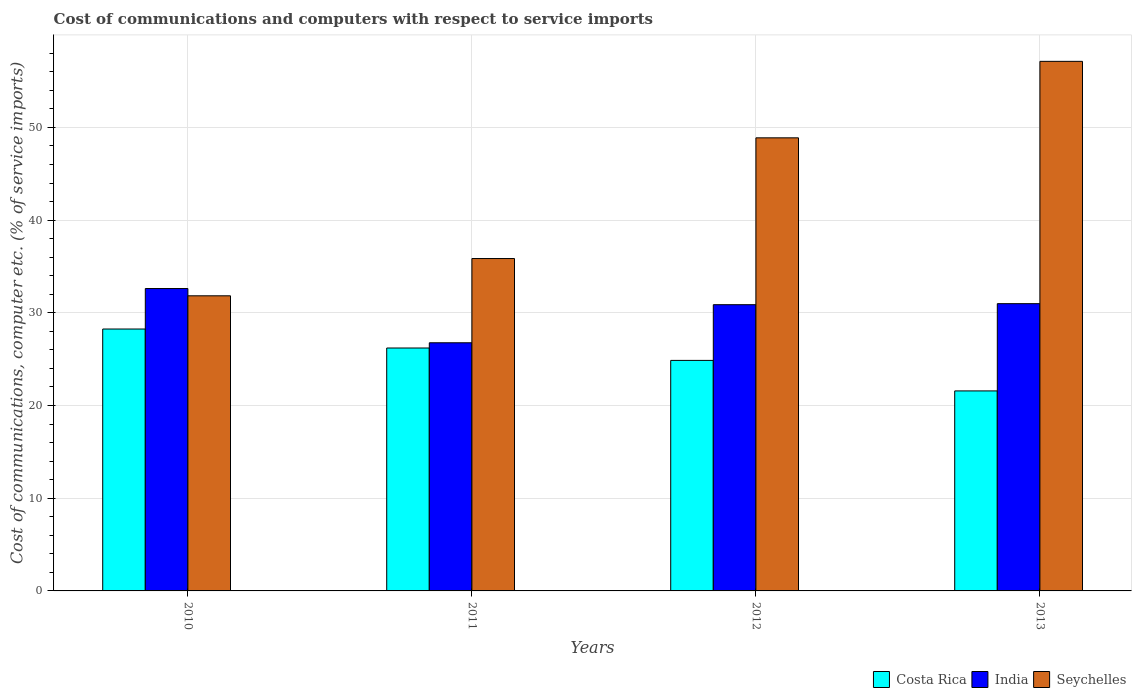How many different coloured bars are there?
Your response must be concise. 3. Are the number of bars on each tick of the X-axis equal?
Your answer should be compact. Yes. How many bars are there on the 4th tick from the left?
Provide a short and direct response. 3. How many bars are there on the 2nd tick from the right?
Give a very brief answer. 3. What is the cost of communications and computers in Costa Rica in 2011?
Make the answer very short. 26.2. Across all years, what is the maximum cost of communications and computers in Seychelles?
Ensure brevity in your answer.  57.13. Across all years, what is the minimum cost of communications and computers in Costa Rica?
Give a very brief answer. 21.58. In which year was the cost of communications and computers in Costa Rica maximum?
Keep it short and to the point. 2010. In which year was the cost of communications and computers in India minimum?
Give a very brief answer. 2011. What is the total cost of communications and computers in Seychelles in the graph?
Offer a very short reply. 173.69. What is the difference between the cost of communications and computers in Costa Rica in 2010 and that in 2011?
Your answer should be compact. 2.05. What is the difference between the cost of communications and computers in Seychelles in 2011 and the cost of communications and computers in India in 2013?
Provide a succinct answer. 4.87. What is the average cost of communications and computers in Seychelles per year?
Offer a very short reply. 43.42. In the year 2012, what is the difference between the cost of communications and computers in Costa Rica and cost of communications and computers in India?
Provide a short and direct response. -6.01. In how many years, is the cost of communications and computers in Costa Rica greater than 28 %?
Ensure brevity in your answer.  1. What is the ratio of the cost of communications and computers in Costa Rica in 2010 to that in 2012?
Your answer should be compact. 1.14. What is the difference between the highest and the second highest cost of communications and computers in Seychelles?
Offer a very short reply. 8.25. What is the difference between the highest and the lowest cost of communications and computers in Seychelles?
Offer a very short reply. 25.29. What does the 2nd bar from the left in 2010 represents?
Your answer should be compact. India. What does the 1st bar from the right in 2012 represents?
Your answer should be compact. Seychelles. How many bars are there?
Ensure brevity in your answer.  12. Are all the bars in the graph horizontal?
Keep it short and to the point. No. What is the difference between two consecutive major ticks on the Y-axis?
Keep it short and to the point. 10. Are the values on the major ticks of Y-axis written in scientific E-notation?
Your response must be concise. No. How many legend labels are there?
Offer a very short reply. 3. What is the title of the graph?
Ensure brevity in your answer.  Cost of communications and computers with respect to service imports. What is the label or title of the Y-axis?
Provide a succinct answer. Cost of communications, computer etc. (% of service imports). What is the Cost of communications, computer etc. (% of service imports) in Costa Rica in 2010?
Your answer should be compact. 28.25. What is the Cost of communications, computer etc. (% of service imports) of India in 2010?
Offer a terse response. 32.62. What is the Cost of communications, computer etc. (% of service imports) of Seychelles in 2010?
Ensure brevity in your answer.  31.83. What is the Cost of communications, computer etc. (% of service imports) of Costa Rica in 2011?
Ensure brevity in your answer.  26.2. What is the Cost of communications, computer etc. (% of service imports) of India in 2011?
Offer a terse response. 26.77. What is the Cost of communications, computer etc. (% of service imports) in Seychelles in 2011?
Your answer should be very brief. 35.86. What is the Cost of communications, computer etc. (% of service imports) in Costa Rica in 2012?
Ensure brevity in your answer.  24.87. What is the Cost of communications, computer etc. (% of service imports) in India in 2012?
Provide a short and direct response. 30.87. What is the Cost of communications, computer etc. (% of service imports) in Seychelles in 2012?
Make the answer very short. 48.88. What is the Cost of communications, computer etc. (% of service imports) of Costa Rica in 2013?
Offer a very short reply. 21.58. What is the Cost of communications, computer etc. (% of service imports) of India in 2013?
Provide a succinct answer. 30.99. What is the Cost of communications, computer etc. (% of service imports) of Seychelles in 2013?
Give a very brief answer. 57.13. Across all years, what is the maximum Cost of communications, computer etc. (% of service imports) in Costa Rica?
Make the answer very short. 28.25. Across all years, what is the maximum Cost of communications, computer etc. (% of service imports) of India?
Your answer should be very brief. 32.62. Across all years, what is the maximum Cost of communications, computer etc. (% of service imports) of Seychelles?
Offer a terse response. 57.13. Across all years, what is the minimum Cost of communications, computer etc. (% of service imports) in Costa Rica?
Offer a very short reply. 21.58. Across all years, what is the minimum Cost of communications, computer etc. (% of service imports) of India?
Your response must be concise. 26.77. Across all years, what is the minimum Cost of communications, computer etc. (% of service imports) in Seychelles?
Ensure brevity in your answer.  31.83. What is the total Cost of communications, computer etc. (% of service imports) of Costa Rica in the graph?
Provide a succinct answer. 100.9. What is the total Cost of communications, computer etc. (% of service imports) in India in the graph?
Make the answer very short. 121.25. What is the total Cost of communications, computer etc. (% of service imports) of Seychelles in the graph?
Your answer should be compact. 173.69. What is the difference between the Cost of communications, computer etc. (% of service imports) in Costa Rica in 2010 and that in 2011?
Provide a succinct answer. 2.05. What is the difference between the Cost of communications, computer etc. (% of service imports) in India in 2010 and that in 2011?
Make the answer very short. 5.85. What is the difference between the Cost of communications, computer etc. (% of service imports) of Seychelles in 2010 and that in 2011?
Keep it short and to the point. -4.02. What is the difference between the Cost of communications, computer etc. (% of service imports) of Costa Rica in 2010 and that in 2012?
Give a very brief answer. 3.38. What is the difference between the Cost of communications, computer etc. (% of service imports) of India in 2010 and that in 2012?
Provide a succinct answer. 1.74. What is the difference between the Cost of communications, computer etc. (% of service imports) of Seychelles in 2010 and that in 2012?
Make the answer very short. -17.04. What is the difference between the Cost of communications, computer etc. (% of service imports) of Costa Rica in 2010 and that in 2013?
Your response must be concise. 6.68. What is the difference between the Cost of communications, computer etc. (% of service imports) of India in 2010 and that in 2013?
Give a very brief answer. 1.63. What is the difference between the Cost of communications, computer etc. (% of service imports) of Seychelles in 2010 and that in 2013?
Offer a terse response. -25.29. What is the difference between the Cost of communications, computer etc. (% of service imports) in Costa Rica in 2011 and that in 2012?
Keep it short and to the point. 1.34. What is the difference between the Cost of communications, computer etc. (% of service imports) of India in 2011 and that in 2012?
Provide a short and direct response. -4.11. What is the difference between the Cost of communications, computer etc. (% of service imports) of Seychelles in 2011 and that in 2012?
Provide a succinct answer. -13.02. What is the difference between the Cost of communications, computer etc. (% of service imports) in Costa Rica in 2011 and that in 2013?
Provide a succinct answer. 4.63. What is the difference between the Cost of communications, computer etc. (% of service imports) of India in 2011 and that in 2013?
Your answer should be compact. -4.22. What is the difference between the Cost of communications, computer etc. (% of service imports) in Seychelles in 2011 and that in 2013?
Make the answer very short. -21.27. What is the difference between the Cost of communications, computer etc. (% of service imports) in Costa Rica in 2012 and that in 2013?
Your response must be concise. 3.29. What is the difference between the Cost of communications, computer etc. (% of service imports) of India in 2012 and that in 2013?
Offer a very short reply. -0.11. What is the difference between the Cost of communications, computer etc. (% of service imports) of Seychelles in 2012 and that in 2013?
Offer a very short reply. -8.25. What is the difference between the Cost of communications, computer etc. (% of service imports) in Costa Rica in 2010 and the Cost of communications, computer etc. (% of service imports) in India in 2011?
Your answer should be very brief. 1.48. What is the difference between the Cost of communications, computer etc. (% of service imports) in Costa Rica in 2010 and the Cost of communications, computer etc. (% of service imports) in Seychelles in 2011?
Offer a terse response. -7.6. What is the difference between the Cost of communications, computer etc. (% of service imports) in India in 2010 and the Cost of communications, computer etc. (% of service imports) in Seychelles in 2011?
Your answer should be compact. -3.24. What is the difference between the Cost of communications, computer etc. (% of service imports) of Costa Rica in 2010 and the Cost of communications, computer etc. (% of service imports) of India in 2012?
Provide a short and direct response. -2.62. What is the difference between the Cost of communications, computer etc. (% of service imports) of Costa Rica in 2010 and the Cost of communications, computer etc. (% of service imports) of Seychelles in 2012?
Make the answer very short. -20.62. What is the difference between the Cost of communications, computer etc. (% of service imports) of India in 2010 and the Cost of communications, computer etc. (% of service imports) of Seychelles in 2012?
Ensure brevity in your answer.  -16.26. What is the difference between the Cost of communications, computer etc. (% of service imports) of Costa Rica in 2010 and the Cost of communications, computer etc. (% of service imports) of India in 2013?
Keep it short and to the point. -2.74. What is the difference between the Cost of communications, computer etc. (% of service imports) of Costa Rica in 2010 and the Cost of communications, computer etc. (% of service imports) of Seychelles in 2013?
Give a very brief answer. -28.87. What is the difference between the Cost of communications, computer etc. (% of service imports) of India in 2010 and the Cost of communications, computer etc. (% of service imports) of Seychelles in 2013?
Ensure brevity in your answer.  -24.51. What is the difference between the Cost of communications, computer etc. (% of service imports) in Costa Rica in 2011 and the Cost of communications, computer etc. (% of service imports) in India in 2012?
Provide a succinct answer. -4.67. What is the difference between the Cost of communications, computer etc. (% of service imports) in Costa Rica in 2011 and the Cost of communications, computer etc. (% of service imports) in Seychelles in 2012?
Keep it short and to the point. -22.67. What is the difference between the Cost of communications, computer etc. (% of service imports) in India in 2011 and the Cost of communications, computer etc. (% of service imports) in Seychelles in 2012?
Give a very brief answer. -22.11. What is the difference between the Cost of communications, computer etc. (% of service imports) of Costa Rica in 2011 and the Cost of communications, computer etc. (% of service imports) of India in 2013?
Offer a terse response. -4.78. What is the difference between the Cost of communications, computer etc. (% of service imports) of Costa Rica in 2011 and the Cost of communications, computer etc. (% of service imports) of Seychelles in 2013?
Provide a succinct answer. -30.92. What is the difference between the Cost of communications, computer etc. (% of service imports) of India in 2011 and the Cost of communications, computer etc. (% of service imports) of Seychelles in 2013?
Offer a terse response. -30.36. What is the difference between the Cost of communications, computer etc. (% of service imports) of Costa Rica in 2012 and the Cost of communications, computer etc. (% of service imports) of India in 2013?
Your answer should be compact. -6.12. What is the difference between the Cost of communications, computer etc. (% of service imports) in Costa Rica in 2012 and the Cost of communications, computer etc. (% of service imports) in Seychelles in 2013?
Your answer should be compact. -32.26. What is the difference between the Cost of communications, computer etc. (% of service imports) of India in 2012 and the Cost of communications, computer etc. (% of service imports) of Seychelles in 2013?
Give a very brief answer. -26.25. What is the average Cost of communications, computer etc. (% of service imports) of Costa Rica per year?
Offer a very short reply. 25.22. What is the average Cost of communications, computer etc. (% of service imports) in India per year?
Your answer should be compact. 30.31. What is the average Cost of communications, computer etc. (% of service imports) in Seychelles per year?
Your response must be concise. 43.42. In the year 2010, what is the difference between the Cost of communications, computer etc. (% of service imports) of Costa Rica and Cost of communications, computer etc. (% of service imports) of India?
Give a very brief answer. -4.37. In the year 2010, what is the difference between the Cost of communications, computer etc. (% of service imports) of Costa Rica and Cost of communications, computer etc. (% of service imports) of Seychelles?
Make the answer very short. -3.58. In the year 2010, what is the difference between the Cost of communications, computer etc. (% of service imports) of India and Cost of communications, computer etc. (% of service imports) of Seychelles?
Your answer should be compact. 0.78. In the year 2011, what is the difference between the Cost of communications, computer etc. (% of service imports) of Costa Rica and Cost of communications, computer etc. (% of service imports) of India?
Keep it short and to the point. -0.56. In the year 2011, what is the difference between the Cost of communications, computer etc. (% of service imports) of Costa Rica and Cost of communications, computer etc. (% of service imports) of Seychelles?
Keep it short and to the point. -9.65. In the year 2011, what is the difference between the Cost of communications, computer etc. (% of service imports) in India and Cost of communications, computer etc. (% of service imports) in Seychelles?
Provide a short and direct response. -9.09. In the year 2012, what is the difference between the Cost of communications, computer etc. (% of service imports) of Costa Rica and Cost of communications, computer etc. (% of service imports) of India?
Provide a short and direct response. -6.01. In the year 2012, what is the difference between the Cost of communications, computer etc. (% of service imports) of Costa Rica and Cost of communications, computer etc. (% of service imports) of Seychelles?
Provide a short and direct response. -24.01. In the year 2012, what is the difference between the Cost of communications, computer etc. (% of service imports) of India and Cost of communications, computer etc. (% of service imports) of Seychelles?
Provide a short and direct response. -18. In the year 2013, what is the difference between the Cost of communications, computer etc. (% of service imports) of Costa Rica and Cost of communications, computer etc. (% of service imports) of India?
Ensure brevity in your answer.  -9.41. In the year 2013, what is the difference between the Cost of communications, computer etc. (% of service imports) in Costa Rica and Cost of communications, computer etc. (% of service imports) in Seychelles?
Provide a short and direct response. -35.55. In the year 2013, what is the difference between the Cost of communications, computer etc. (% of service imports) in India and Cost of communications, computer etc. (% of service imports) in Seychelles?
Make the answer very short. -26.14. What is the ratio of the Cost of communications, computer etc. (% of service imports) of Costa Rica in 2010 to that in 2011?
Offer a very short reply. 1.08. What is the ratio of the Cost of communications, computer etc. (% of service imports) of India in 2010 to that in 2011?
Keep it short and to the point. 1.22. What is the ratio of the Cost of communications, computer etc. (% of service imports) of Seychelles in 2010 to that in 2011?
Ensure brevity in your answer.  0.89. What is the ratio of the Cost of communications, computer etc. (% of service imports) of Costa Rica in 2010 to that in 2012?
Provide a short and direct response. 1.14. What is the ratio of the Cost of communications, computer etc. (% of service imports) in India in 2010 to that in 2012?
Give a very brief answer. 1.06. What is the ratio of the Cost of communications, computer etc. (% of service imports) in Seychelles in 2010 to that in 2012?
Offer a very short reply. 0.65. What is the ratio of the Cost of communications, computer etc. (% of service imports) in Costa Rica in 2010 to that in 2013?
Your answer should be very brief. 1.31. What is the ratio of the Cost of communications, computer etc. (% of service imports) of India in 2010 to that in 2013?
Your answer should be compact. 1.05. What is the ratio of the Cost of communications, computer etc. (% of service imports) in Seychelles in 2010 to that in 2013?
Your response must be concise. 0.56. What is the ratio of the Cost of communications, computer etc. (% of service imports) in Costa Rica in 2011 to that in 2012?
Your answer should be very brief. 1.05. What is the ratio of the Cost of communications, computer etc. (% of service imports) in India in 2011 to that in 2012?
Give a very brief answer. 0.87. What is the ratio of the Cost of communications, computer etc. (% of service imports) in Seychelles in 2011 to that in 2012?
Offer a very short reply. 0.73. What is the ratio of the Cost of communications, computer etc. (% of service imports) in Costa Rica in 2011 to that in 2013?
Your answer should be compact. 1.21. What is the ratio of the Cost of communications, computer etc. (% of service imports) of India in 2011 to that in 2013?
Keep it short and to the point. 0.86. What is the ratio of the Cost of communications, computer etc. (% of service imports) in Seychelles in 2011 to that in 2013?
Offer a very short reply. 0.63. What is the ratio of the Cost of communications, computer etc. (% of service imports) in Costa Rica in 2012 to that in 2013?
Offer a very short reply. 1.15. What is the ratio of the Cost of communications, computer etc. (% of service imports) of Seychelles in 2012 to that in 2013?
Your answer should be compact. 0.86. What is the difference between the highest and the second highest Cost of communications, computer etc. (% of service imports) of Costa Rica?
Provide a short and direct response. 2.05. What is the difference between the highest and the second highest Cost of communications, computer etc. (% of service imports) in India?
Your response must be concise. 1.63. What is the difference between the highest and the second highest Cost of communications, computer etc. (% of service imports) in Seychelles?
Provide a succinct answer. 8.25. What is the difference between the highest and the lowest Cost of communications, computer etc. (% of service imports) of Costa Rica?
Offer a terse response. 6.68. What is the difference between the highest and the lowest Cost of communications, computer etc. (% of service imports) in India?
Offer a very short reply. 5.85. What is the difference between the highest and the lowest Cost of communications, computer etc. (% of service imports) of Seychelles?
Keep it short and to the point. 25.29. 